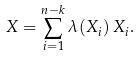Convert formula to latex. <formula><loc_0><loc_0><loc_500><loc_500>X = \sum _ { i = 1 } ^ { n - k } \lambda ( X _ { i } ) \, X _ { i } .</formula> 